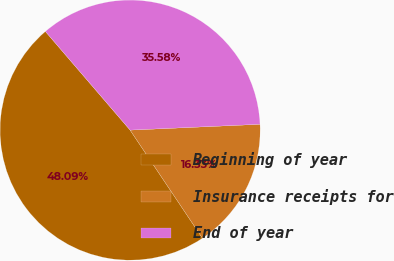Convert chart. <chart><loc_0><loc_0><loc_500><loc_500><pie_chart><fcel>Beginning of year<fcel>Insurance receipts for<fcel>End of year<nl><fcel>48.09%<fcel>16.33%<fcel>35.58%<nl></chart> 